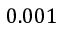<formula> <loc_0><loc_0><loc_500><loc_500>0 . 0 0 1</formula> 